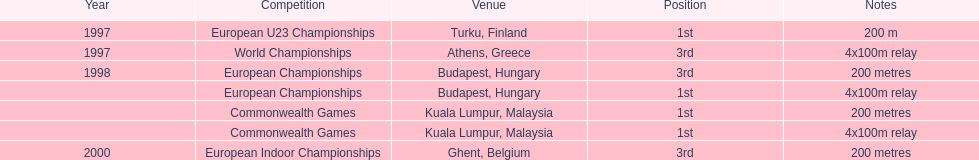Can you give me this table as a dict? {'header': ['Year', 'Competition', 'Venue', 'Position', 'Notes'], 'rows': [['1997', 'European U23 Championships', 'Turku, Finland', '1st', '200 m'], ['1997', 'World Championships', 'Athens, Greece', '3rd', '4x100m relay'], ['1998', 'European Championships', 'Budapest, Hungary', '3rd', '200 metres'], ['', 'European Championships', 'Budapest, Hungary', '1st', '4x100m relay'], ['', 'Commonwealth Games', 'Kuala Lumpur, Malaysia', '1st', '200 metres'], ['', 'Commonwealth Games', 'Kuala Lumpur, Malaysia', '1st', '4x100m relay'], ['2000', 'European Indoor Championships', 'Ghent, Belgium', '3rd', '200 metres']]} How long was the sprint from the european indoor championships competition in 2000? 200 metres. 